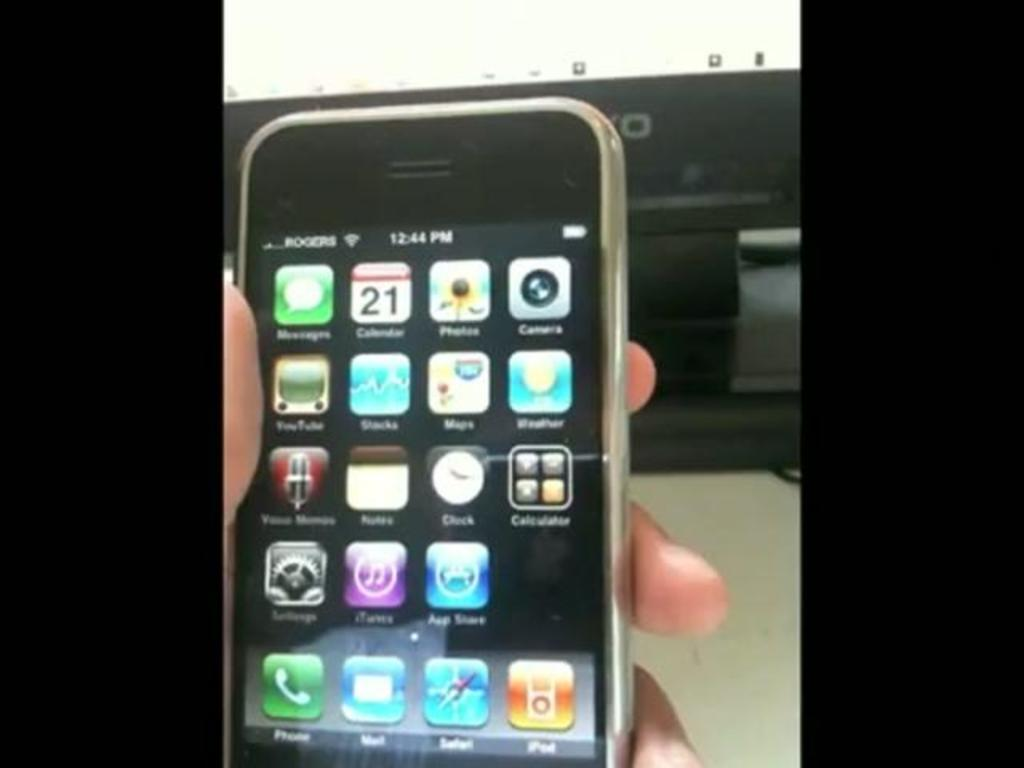<image>
Summarize the visual content of the image. A cell phone screen displaying different apps including the camera 